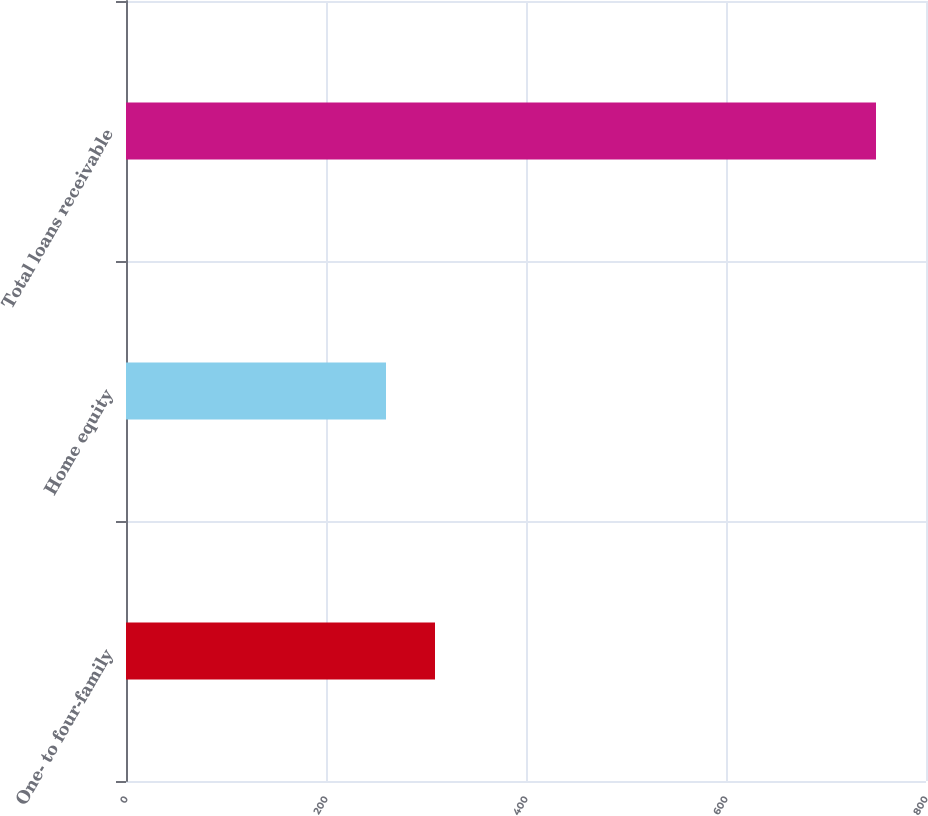<chart> <loc_0><loc_0><loc_500><loc_500><bar_chart><fcel>One- to four-family<fcel>Home equity<fcel>Total loans receivable<nl><fcel>309<fcel>260<fcel>750<nl></chart> 